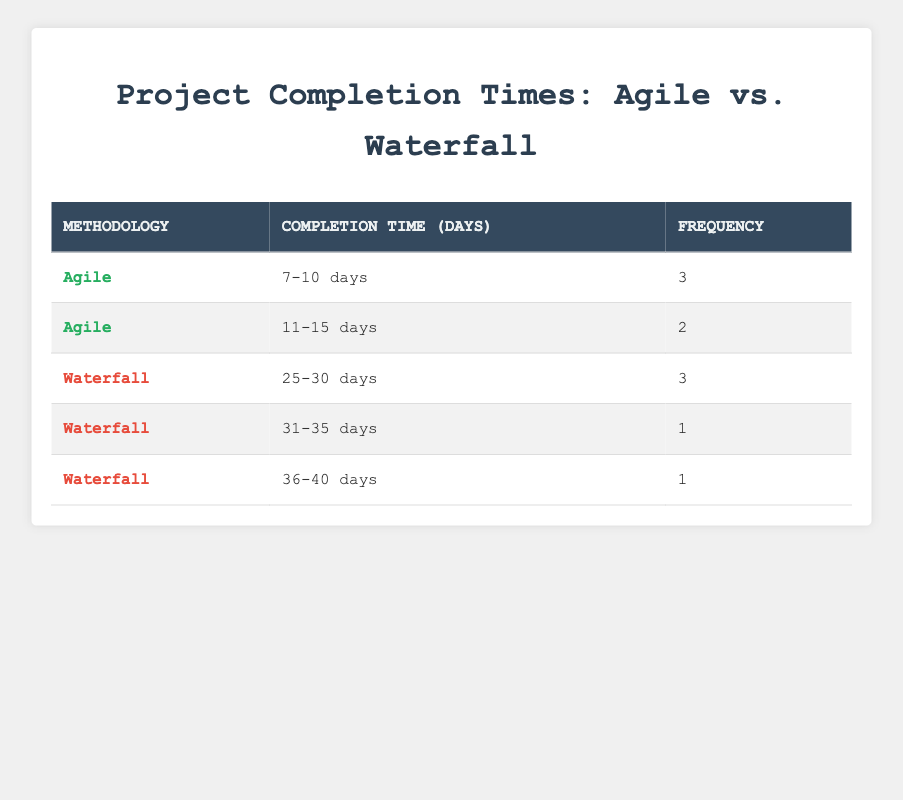What is the frequency of projects completed in 11-15 days using Agile methodology? In the Agile row for the completion time of 11-15 days, the frequency column indicates a value of 2.
Answer: 2 How many projects were completed in total using the Waterfall methodology? By counting the frequencies of all Waterfall rows, we have 3 (25-30 days) + 1 (31-35 days) + 1 (36-40 days) = 5 projects.
Answer: 5 What completion time range has the highest frequency for Agile projects? The Agile completion time range of 7-10 days has a frequency of 3, which is higher than the frequency of 2 for the 11-15 days range.
Answer: 7-10 days Is it true that the Waterfall methodology had more projects completed in the 25-30 days range than the 31-35 days range? Yes, the frequency for the 25-30 days range is 3, while the frequency for the 31-35 days range is 1, indicating that more projects were completed in the former range.
Answer: Yes What is the total frequency of projects completed in 7-10 days and 25-30 days combined? The frequency for Agile projects completed in 7-10 days is 3, and for Waterfall in the 25-30 days range is also 3. Adding these together gives us 3 + 3 = 6.
Answer: 6 How many completion time categories are there for Agile methodology? There are two categories for Agile methodology: 7-10 days and 11-15 days, as seen in the table.
Answer: 2 Are there any Agile projects that were completed in more than 15 days? No, all Agile project completion times listed are 15 days or less, so there are none above that threshold.
Answer: No What is the average completion time for Waterfall projects based on the provided ranges? Calculating the average involves summing the midpoints of the completion time ranges multiplied by their frequencies, then dividing by the total frequency. The calculation is: ((27.5 * 3) + (33 * 1) + (38 * 1)) / 5 = (82.5 + 33 + 38) / 5 = 153.5 / 5 = 30.7 days.
Answer: 30.7 days 